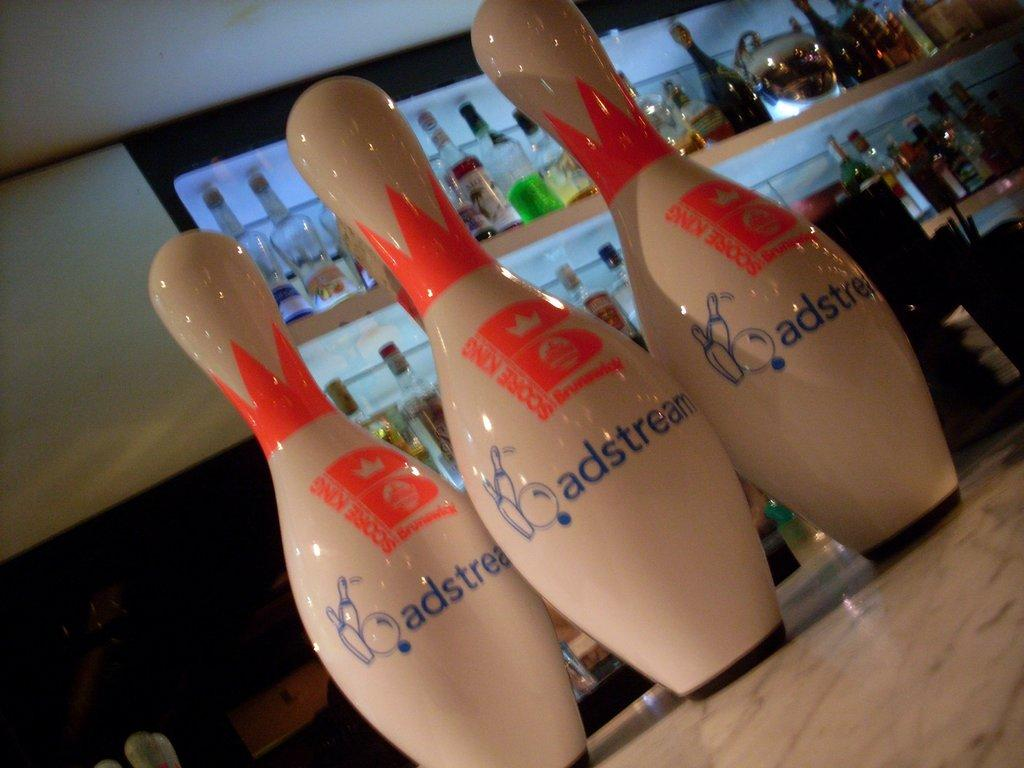<image>
Summarize the visual content of the image. Three bowling pins with adstream advertisement on them sitting on bar countertop. 